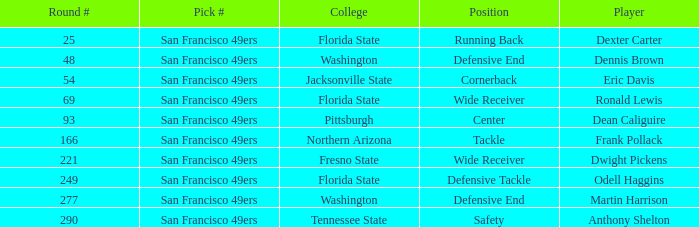What is the College with a Player that is dean caliguire? Pittsburgh. 